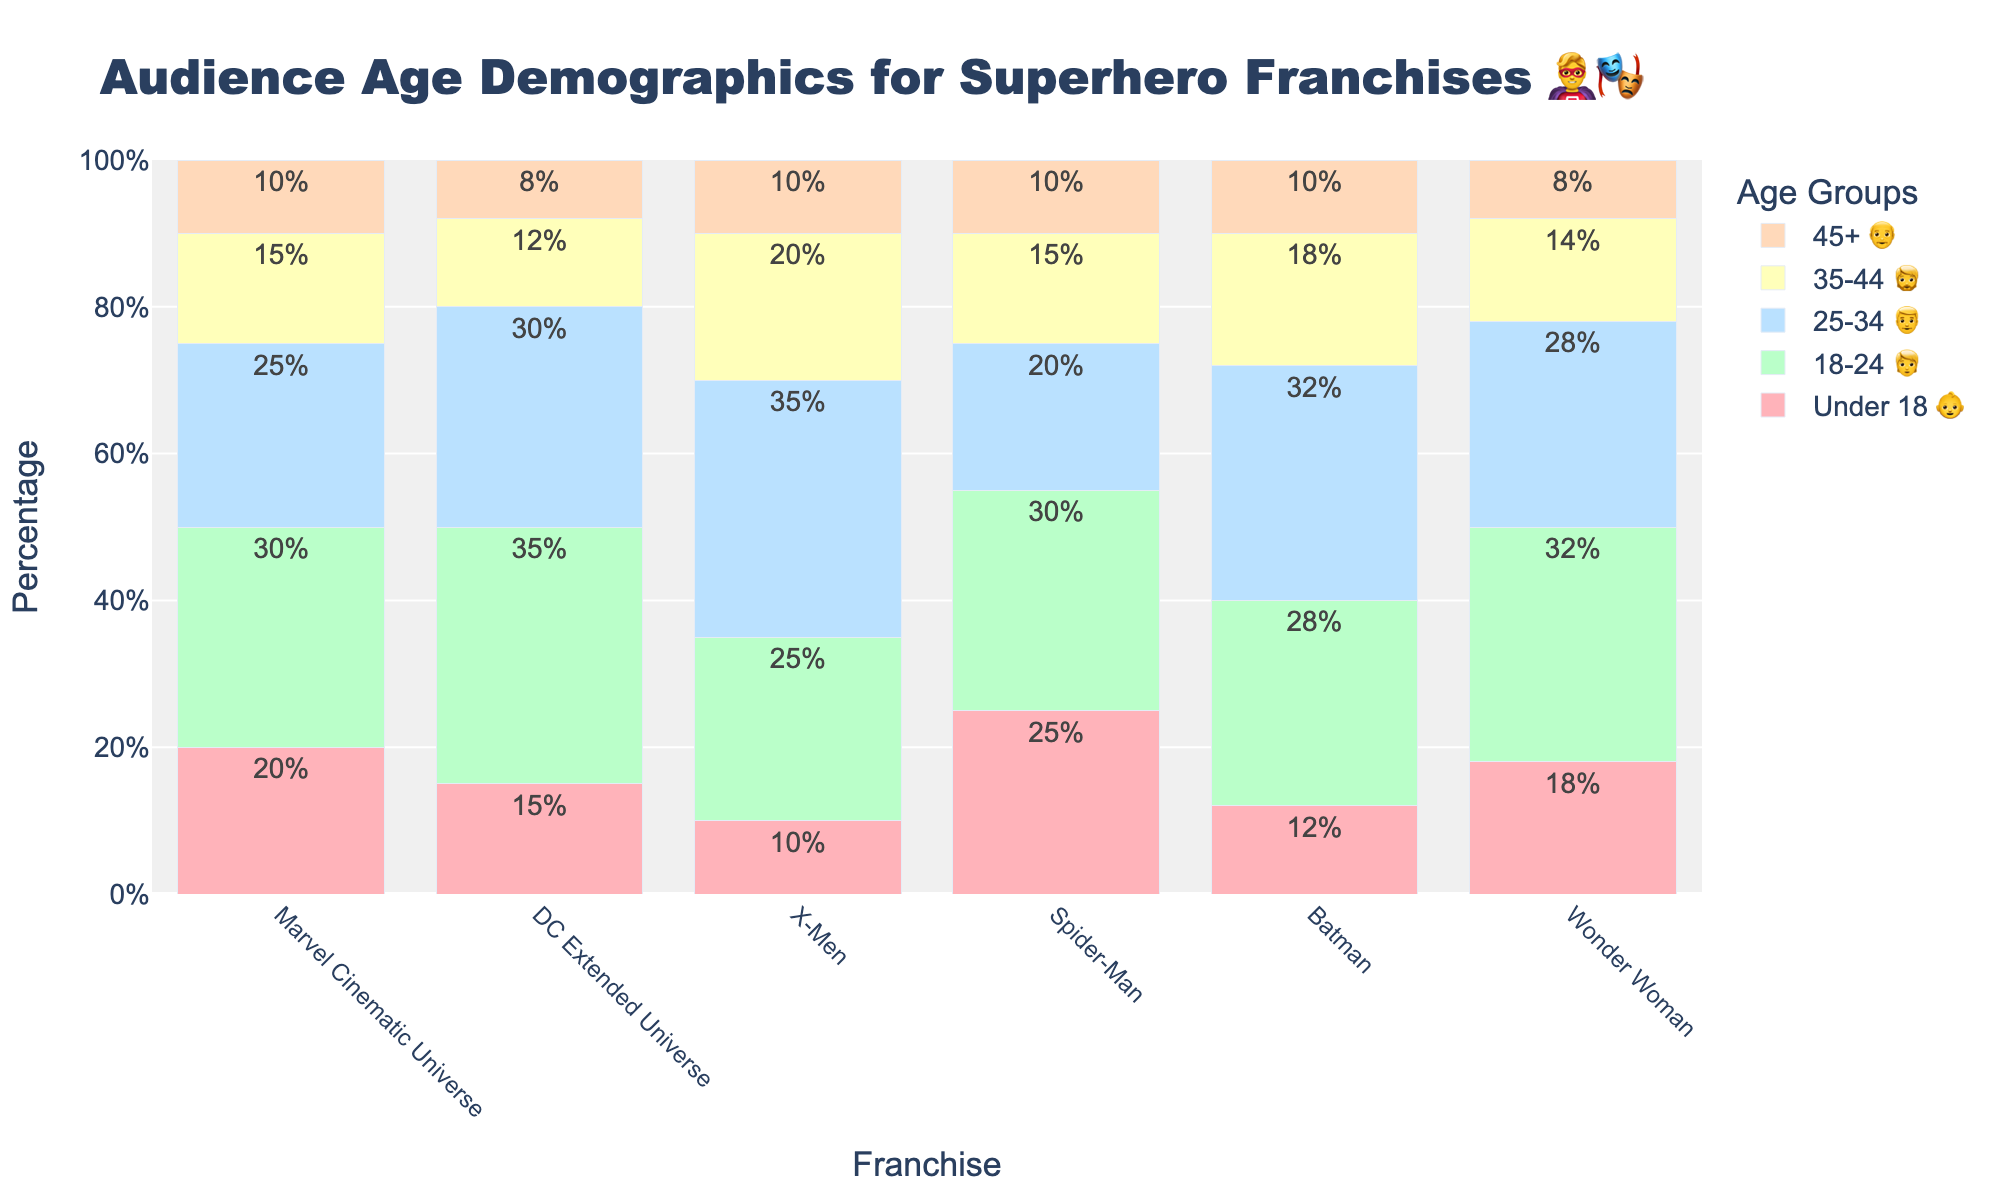What's the title of the chart? The title is located at the top of the chart in bold text.
Answer: Audience Age Demographics for Superhero Franchises 🦸‍♂️🎭 How many superhero franchises are represented in the chart? Look at the x-axis, which lists each franchise name. Count all the unique names.
Answer: Six Which franchise has the highest percentage of viewers under the age of 18? Identify the tallest bar within the "Under 18" category across all franchises.
Answer: Spider-Man What is the total percentage of viewers aged 25-34 for the Marvel Cinematic Universe (MCU) and DC Extended Universe combined? Add the percentage of viewers aged 25-34 for MCU and DC from their respective bars.
Answer: 25% (MCU) + 30% (DC) = 55% Which age group has the smallest percentage of viewers for the Batman franchise? Locate the bars for the Batman franchise and identify the shortest bar.
Answer: 45+ Which franchise has a more balanced audience distribution across all age groups? Compare the height of the bars for each franchise; a "balanced" distribution means that the heights of the bars are relatively similar.
Answer: Wonder Woman By how much does the percentage of viewers aged 18-24 for DC Extended Universe exceed that for X-Men? Subtract the percentage of the 18-24 age group for X-Men from the corresponding percentage for DC Extended Universe.
Answer: 35% (DC) - 25% (X-Men) = 10% What is the average percentage of viewers aged 35-44 across all franchises? Add the percentages for the 35-44 age group from each franchise and divide by the number of franchises.
Answer: (15 + 12 + 20 + 15 + 18 + 14) / 6 = 15.67% What franchise has the lowest percentage of viewers aged 45 and older? Identify the shortest bar in the "45+" age group across all franchises.
Answer: DC Extended Universe and Wonder Woman (tie) For the X-Men franchise, what is the combined percentage of viewers under 18 and aged 45+? Add the percentages of the two age groups for the X-Men franchise.
Answer: 10% (Under 18) + 10% (45+) = 20% 